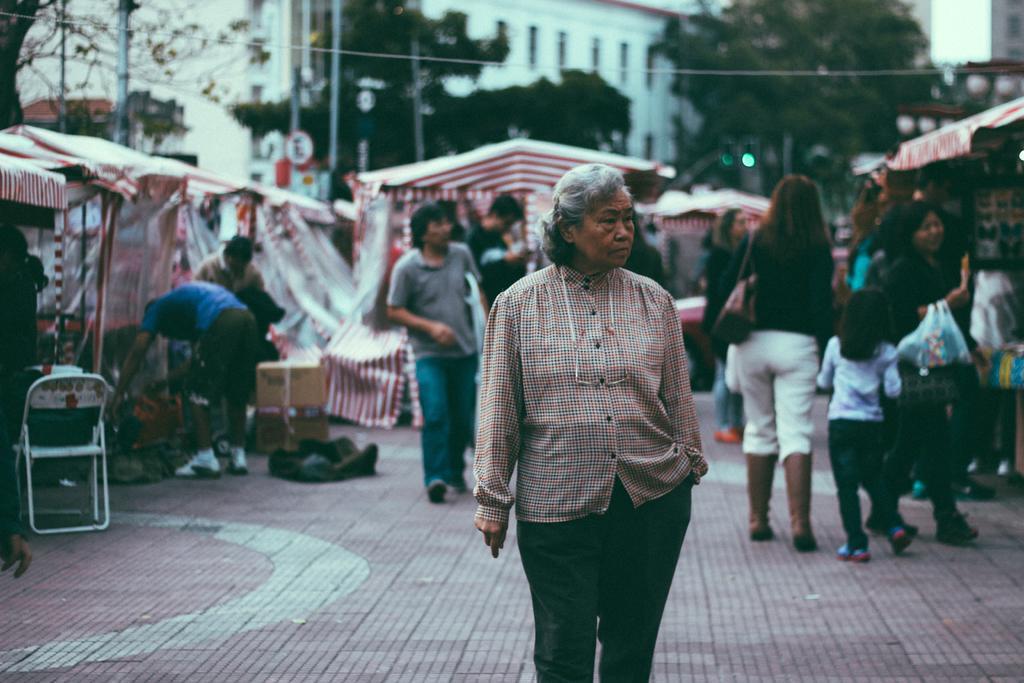Could you give a brief overview of what you see in this image? This image consists of many people. In the front, there is a woman standing on the road. At the bottom, there is a road. On the left and right, there are tents. In the background, there are trees along with a building. On the left, we can see a chair. 